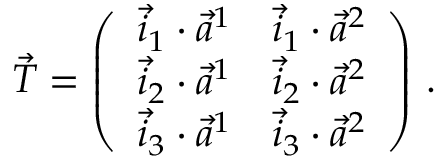<formula> <loc_0><loc_0><loc_500><loc_500>\vec { T } = \left ( \begin{array} { l l } { \vec { i } _ { 1 } \cdot \vec { a } ^ { 1 } } & { \vec { i } _ { 1 } \cdot \vec { a } ^ { 2 } } \\ { \vec { i } _ { 2 } \cdot \vec { a } ^ { 1 } } & { \vec { i } _ { 2 } \cdot \vec { a } ^ { 2 } } \\ { \vec { i } _ { 3 } \cdot \vec { a } ^ { 1 } } & { \vec { i } _ { 3 } \cdot \vec { a } ^ { 2 } } \end{array} \right ) \, .</formula> 